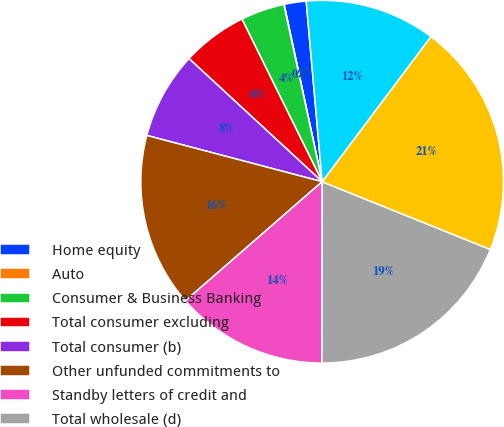Convert chart. <chart><loc_0><loc_0><loc_500><loc_500><pie_chart><fcel>Home equity<fcel>Auto<fcel>Consumer & Business Banking<fcel>Total consumer excluding<fcel>Total consumer (b)<fcel>Other unfunded commitments to<fcel>Standby letters of credit and<fcel>Total wholesale (d)<fcel>Total lending-related<fcel>Derivatives qualifying as<nl><fcel>1.96%<fcel>0.03%<fcel>3.9%<fcel>5.83%<fcel>7.77%<fcel>15.51%<fcel>13.57%<fcel>18.93%<fcel>20.86%<fcel>11.64%<nl></chart> 